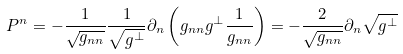<formula> <loc_0><loc_0><loc_500><loc_500>P ^ { n } = - \frac { 1 } { \sqrt { g _ { n n } } } \frac { 1 } { \sqrt { g ^ { \perp } } } \partial _ { n } \left ( g _ { n n } g ^ { \perp } \frac { 1 } { g _ { n n } } \right ) = - \frac { 2 } { \sqrt { g _ { n n } } } \partial _ { n } \sqrt { g ^ { \perp } }</formula> 